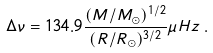Convert formula to latex. <formula><loc_0><loc_0><loc_500><loc_500>\Delta \nu = 1 3 4 . 9 \frac { ( M / M _ { \odot } ) ^ { 1 / 2 } } { ( R / R _ { \odot } ) ^ { 3 / 2 } } \mu H z \, .</formula> 